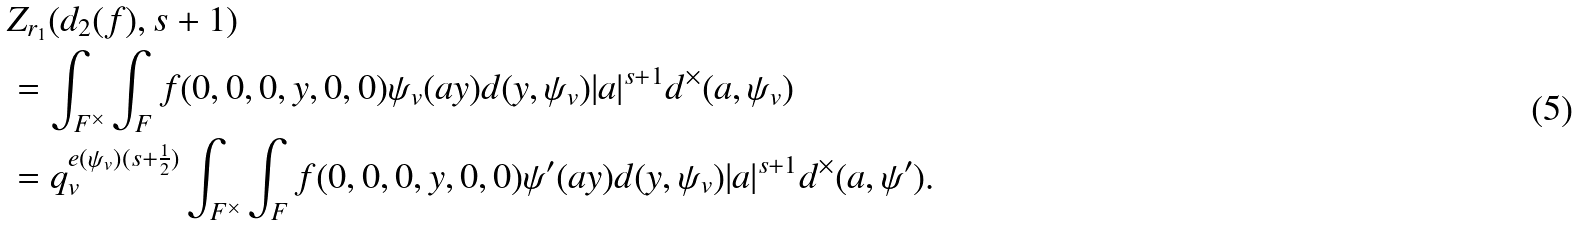Convert formula to latex. <formula><loc_0><loc_0><loc_500><loc_500>& Z _ { r _ { 1 } } ( d _ { 2 } ( f ) , s + 1 ) \\ & = \int _ { F ^ { \times } } \int _ { F } f ( 0 , 0 , 0 , y , 0 , 0 ) \psi _ { v } ( a y ) d ( y , \psi _ { v } ) | a | ^ { s + 1 } d ^ { \times } ( a , \psi _ { v } ) \\ & = q _ { v } ^ { e ( \psi _ { v } ) ( s + \frac { 1 } { 2 } ) } \int _ { F ^ { \times } } \int _ { F } f ( 0 , 0 , 0 , y , 0 , 0 ) \psi ^ { \prime } ( a y ) d ( y , \psi _ { v } ) | a | ^ { s + 1 } d ^ { \times } ( a , \psi ^ { \prime } ) .</formula> 